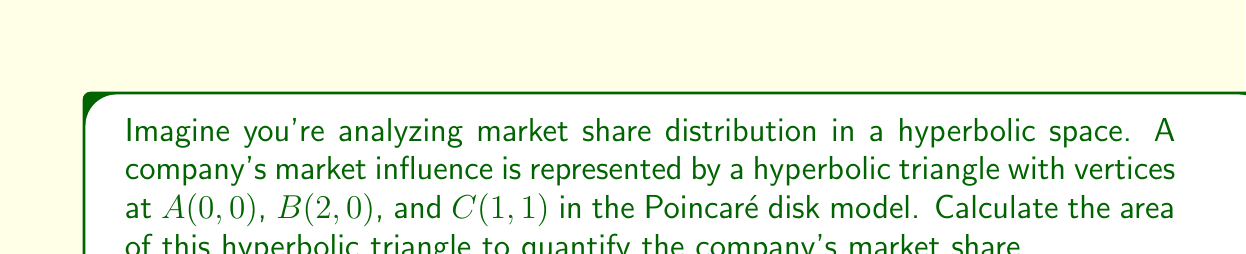What is the answer to this math problem? To solve this problem, we'll use the formula for the area of a hyperbolic triangle in the Poincaré disk model:

$$A = \pi - (\alpha + \beta + \gamma)$$

Where $\alpha$, $\beta$, and $\gamma$ are the angles of the hyperbolic triangle.

Step 1: Calculate the angles of the hyperbolic triangle.

In the Poincaré disk model, we can use the following formula to find the angle between two geodesics:

$$\cos \theta = \frac{(1+|z_1|^2)(1+|z_2|^2) - 4\text{Re}(z_1\overline{z_2})}{(1-|z_1|^2)(1-|z_2|^2)}$$

Where $z_1$ and $z_2$ are the complex numbers representing the endpoints of the geodesics.

For angle $\alpha$ at A(0, 0):
$z_1 = 2, z_2 = 1+i$
$$\cos \alpha = \frac{(1+4)(1+2) - 4\text{Re}(2(1-i))}{(1-4)(1-2)} = \frac{15-8}{3} = \frac{7}{3}$$
$$\alpha = \arccos(\frac{7}{3}) \approx 0.7297$$

For angle $\beta$ at B(2, 0):
$z_1 = -2, z_2 = -1+i$
$$\cos \beta = \frac{(1+4)(1+2) - 4\text{Re}(-2(-1+i))}{(1-4)(1-2)} = \frac{15-8}{3} = \frac{7}{3}$$
$$\beta = \arccos(\frac{7}{3}) \approx 0.7297$$

For angle $\gamma$ at C(1, 1):
$z_1 = -1-i, z_2 = 1-i$
$$\cos \gamma = \frac{(1+2)(1+2) - 4\text{Re}((-1-i)(1+i))}{(1-2)(1-2)} = \frac{9-8}{1} = 1$$
$$\gamma = \arccos(1) = 0$$

Step 2: Apply the area formula.

$$A = \pi - (0.7297 + 0.7297 + 0) \approx 1.6822$$

Therefore, the area of the hyperbolic triangle representing the company's market share is approximately 1.6822 square units in the Poincaré disk model.
Answer: $1.6822$ square units 